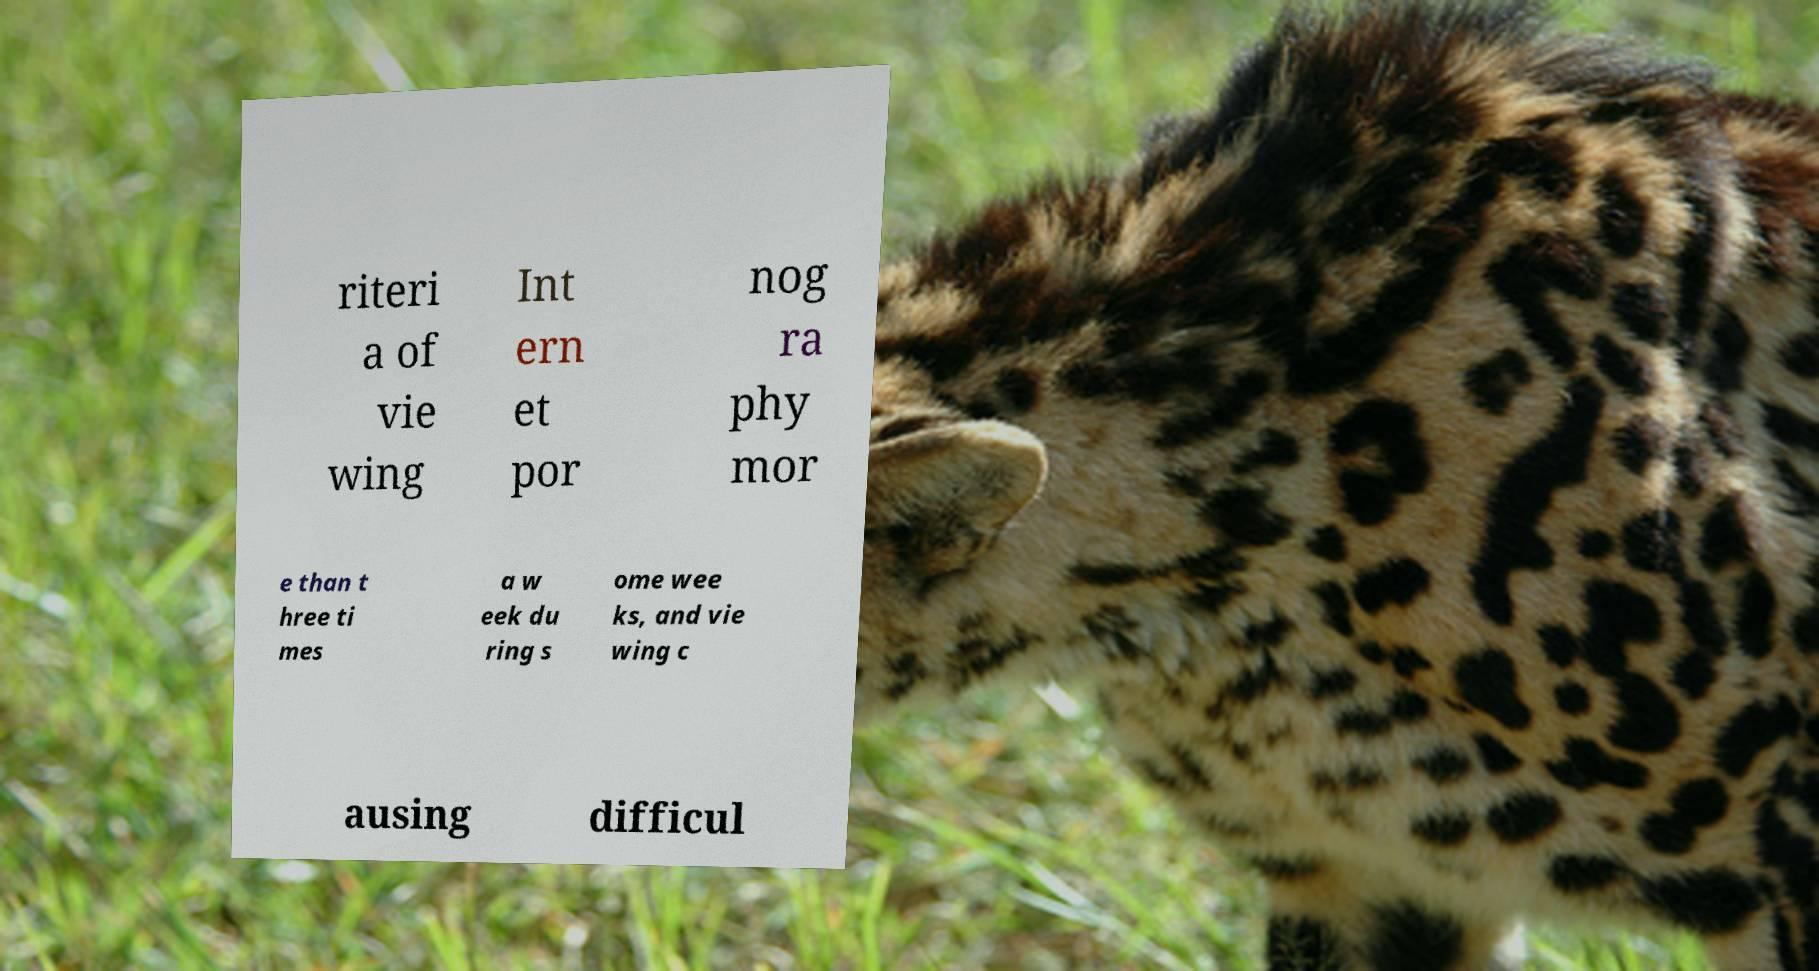Could you assist in decoding the text presented in this image and type it out clearly? riteri a of vie wing Int ern et por nog ra phy mor e than t hree ti mes a w eek du ring s ome wee ks, and vie wing c ausing difficul 